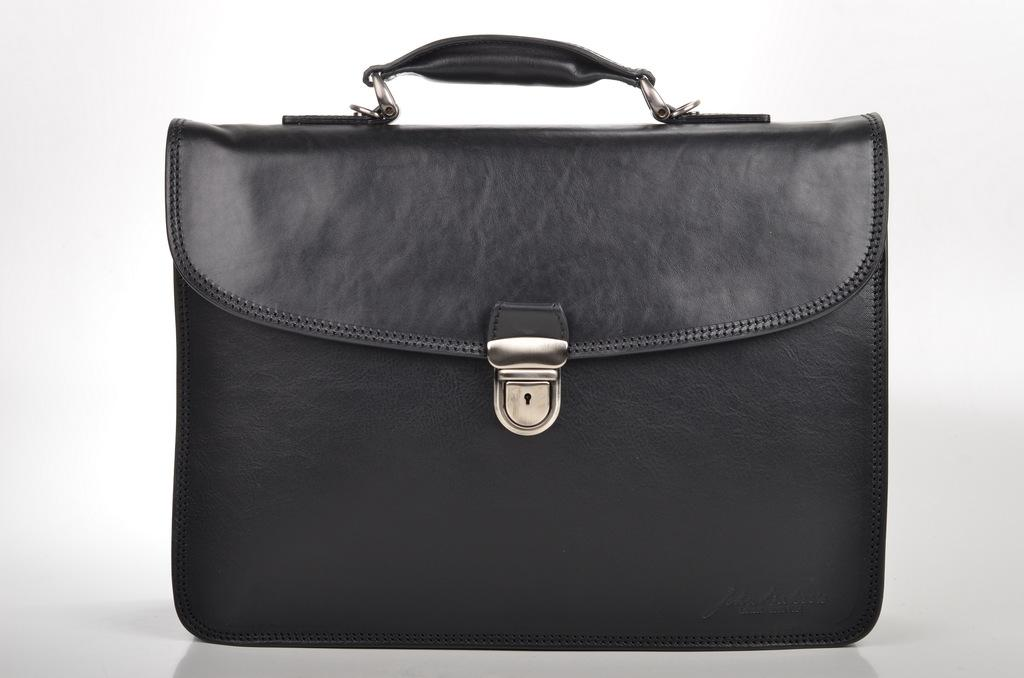What object can be seen in the image? There is a bag in the image. What type of eggnog is being served by the manager in the image? There is no manager or eggnog present in the image; it only features a bag. How is the bag being used for transport in the image? The image does not show the bag being used for transport or any other specific action. 